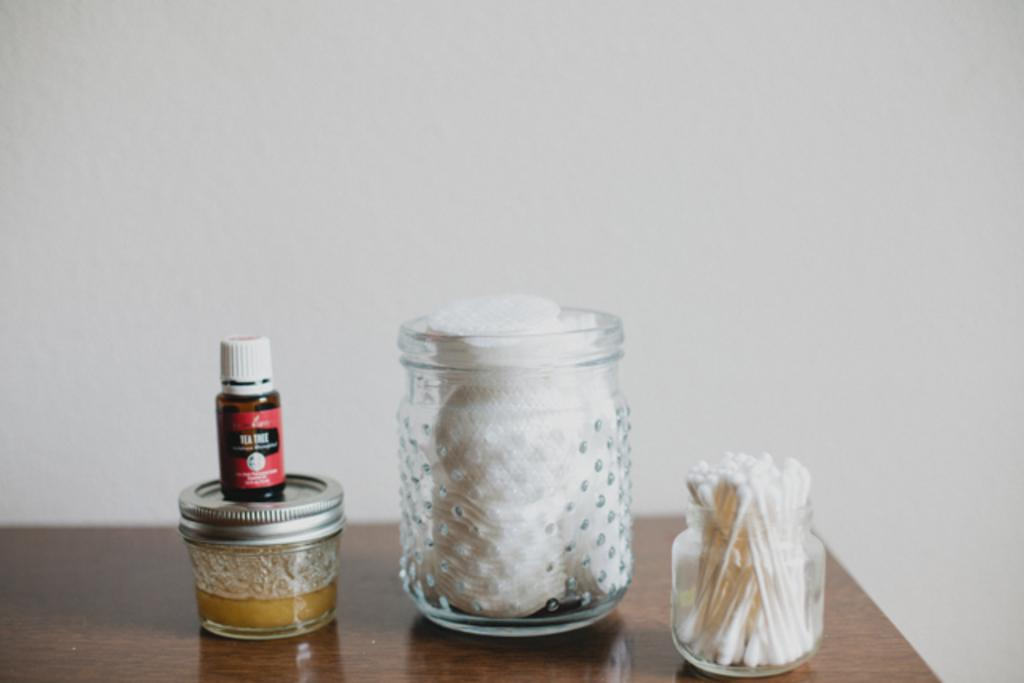How many jars are visible in the image? There are two jars in the image. What is inside each jar? One jar contains cotton, and the other jar contains earbuds. What else can be seen on the table in the image? There are bottles on the table, and they are stacked one over the other. How many babies are crawling on the table in the image? There are no babies present in the image; it only shows jars, earbuds, cotton, and bottles. Is there a slope visible in the image? There is no slope present in the image; it is a flat table with jars and bottles on it. 